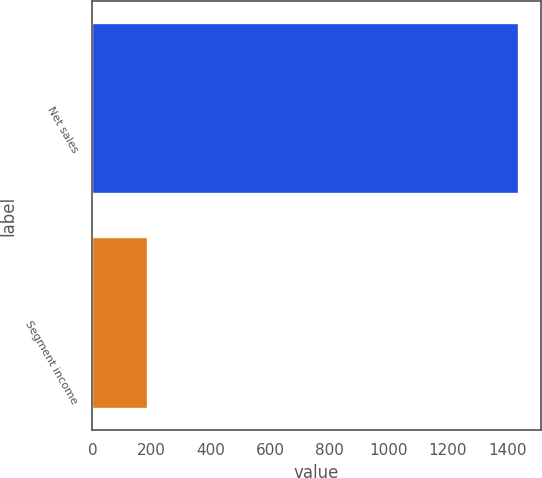Convert chart to OTSL. <chart><loc_0><loc_0><loc_500><loc_500><bar_chart><fcel>Net sales<fcel>Segment income<nl><fcel>1441.6<fcel>187.2<nl></chart> 